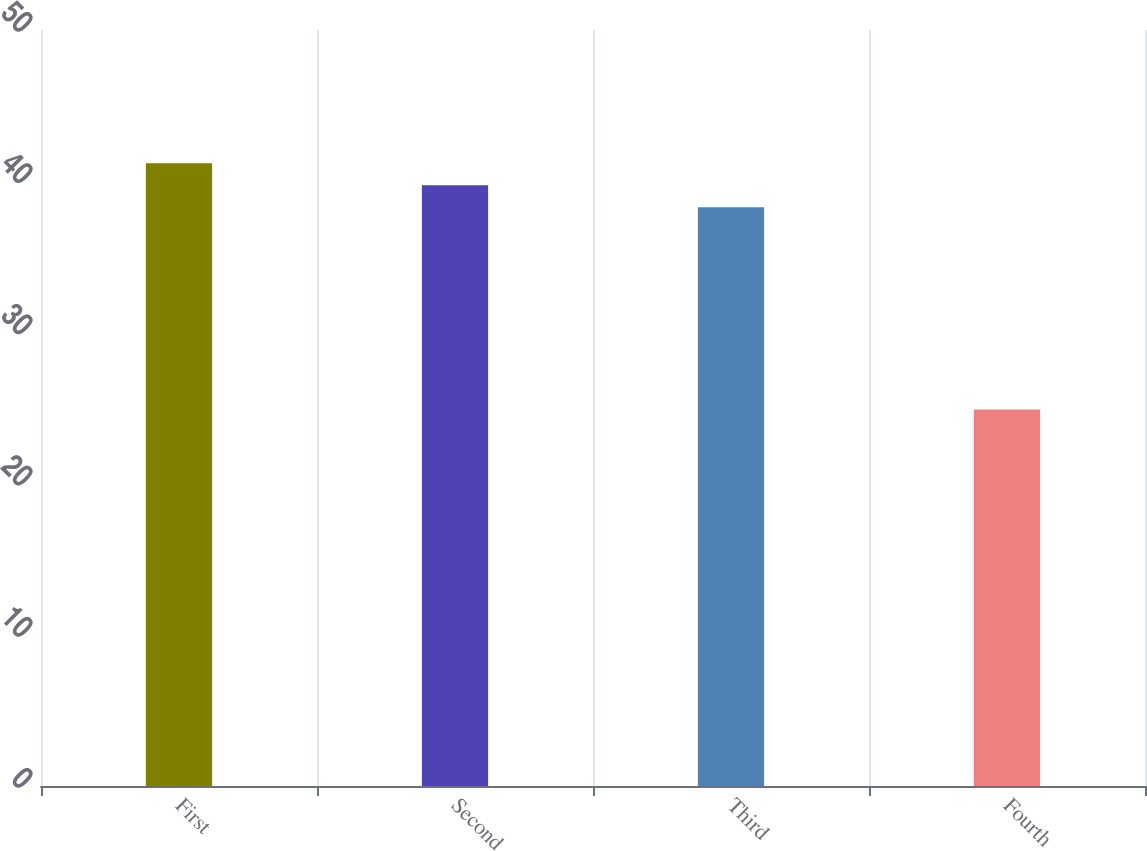Convert chart. <chart><loc_0><loc_0><loc_500><loc_500><bar_chart><fcel>First<fcel>Second<fcel>Third<fcel>Fourth<nl><fcel>41.19<fcel>39.73<fcel>38.27<fcel>24.9<nl></chart> 